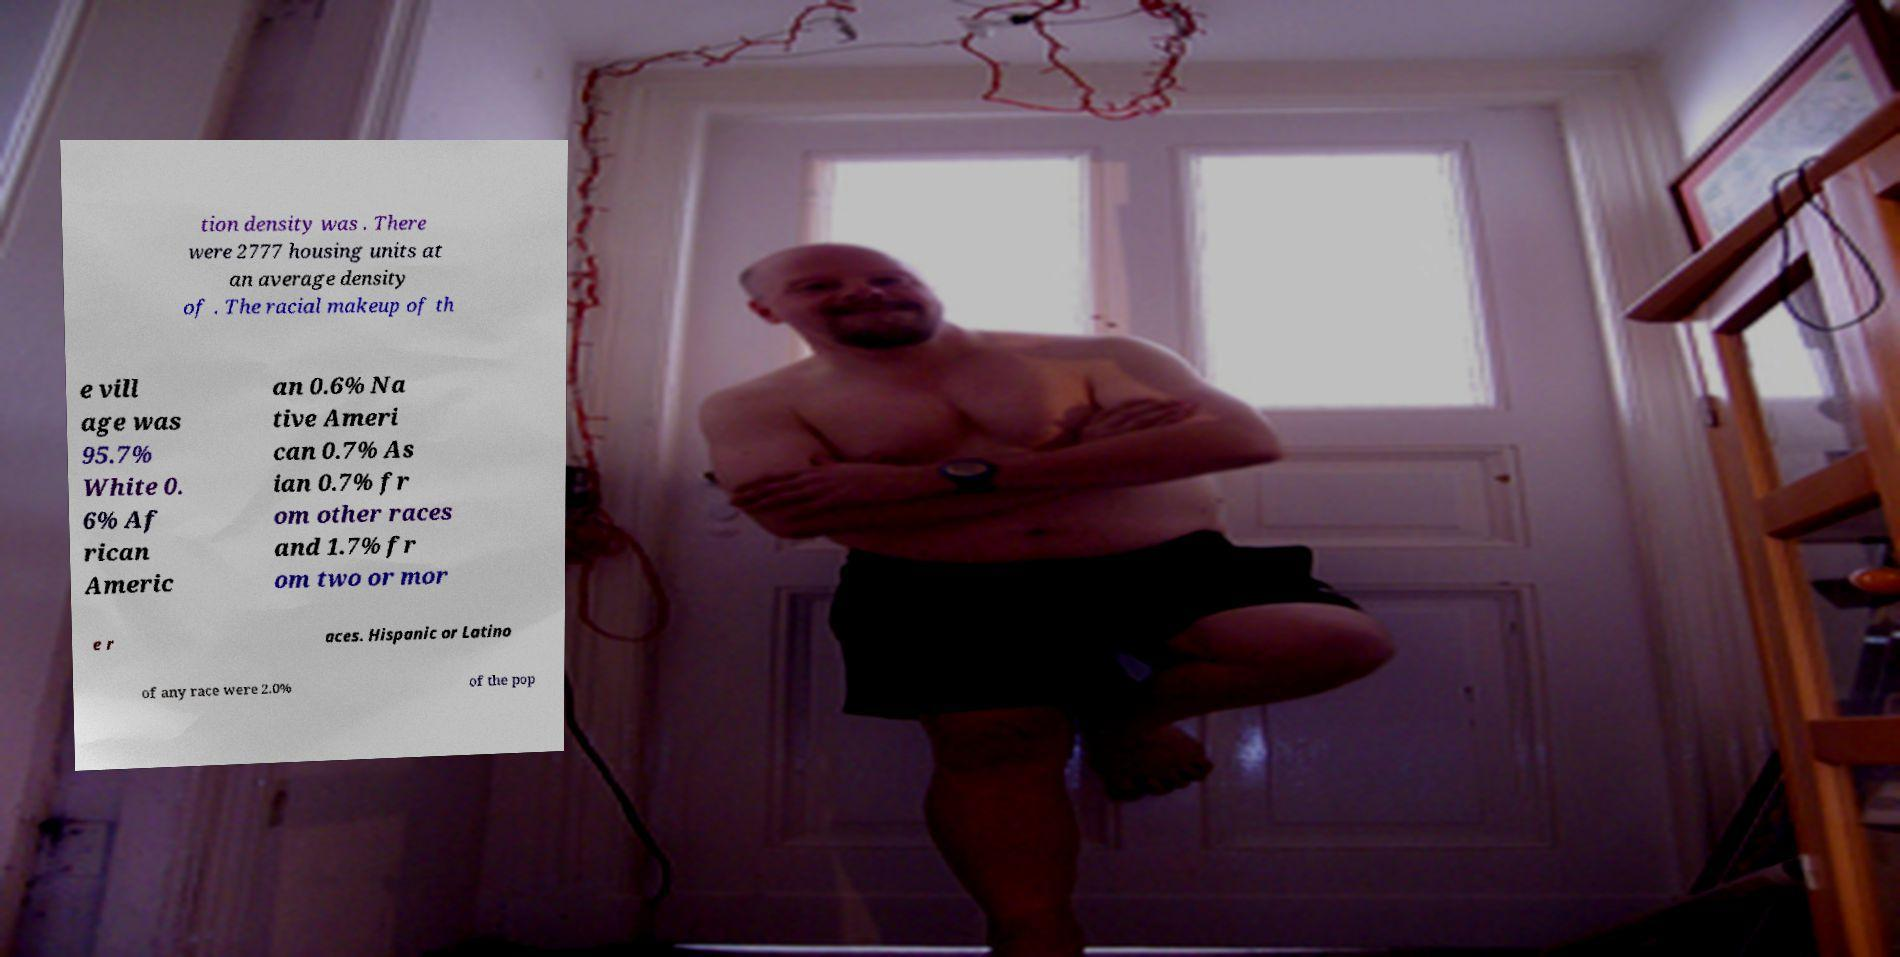What messages or text are displayed in this image? I need them in a readable, typed format. tion density was . There were 2777 housing units at an average density of . The racial makeup of th e vill age was 95.7% White 0. 6% Af rican Americ an 0.6% Na tive Ameri can 0.7% As ian 0.7% fr om other races and 1.7% fr om two or mor e r aces. Hispanic or Latino of any race were 2.0% of the pop 